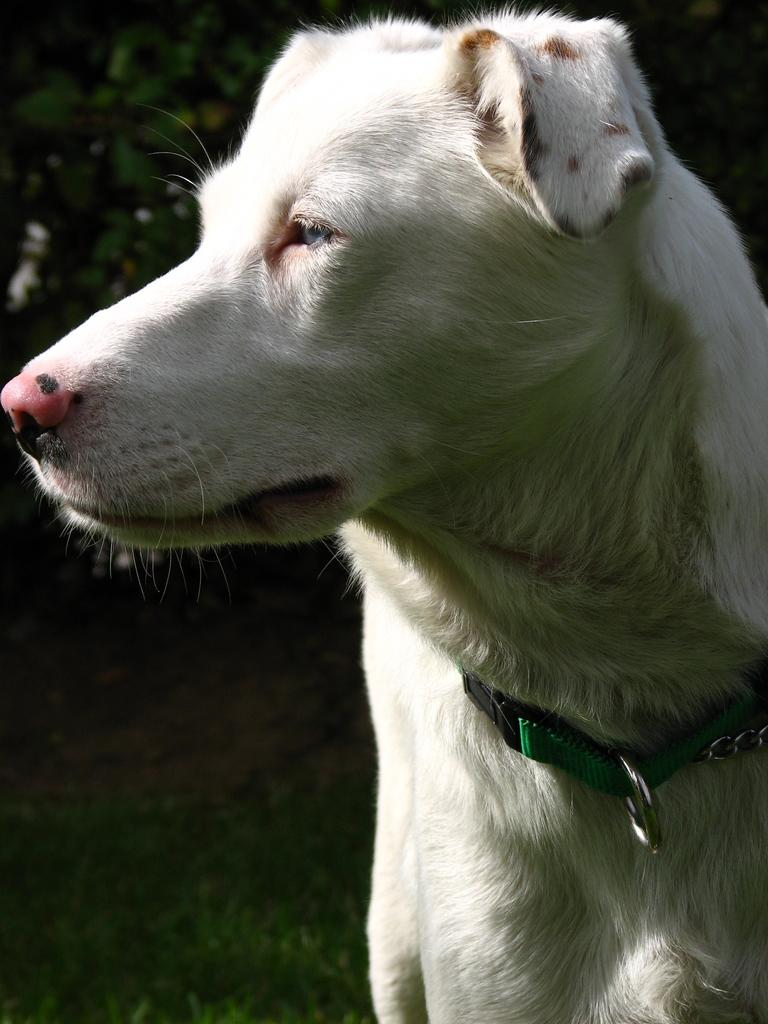What type of animal is in the image? There is a dog in the image. What is the ground surface like in the image? The ground is covered with grass. What other living organisms can be seen in the image? There are plants visible in the image. What type of breakfast is the dog eating in the image? There is no breakfast present in the image; it only features a dog and plants. 